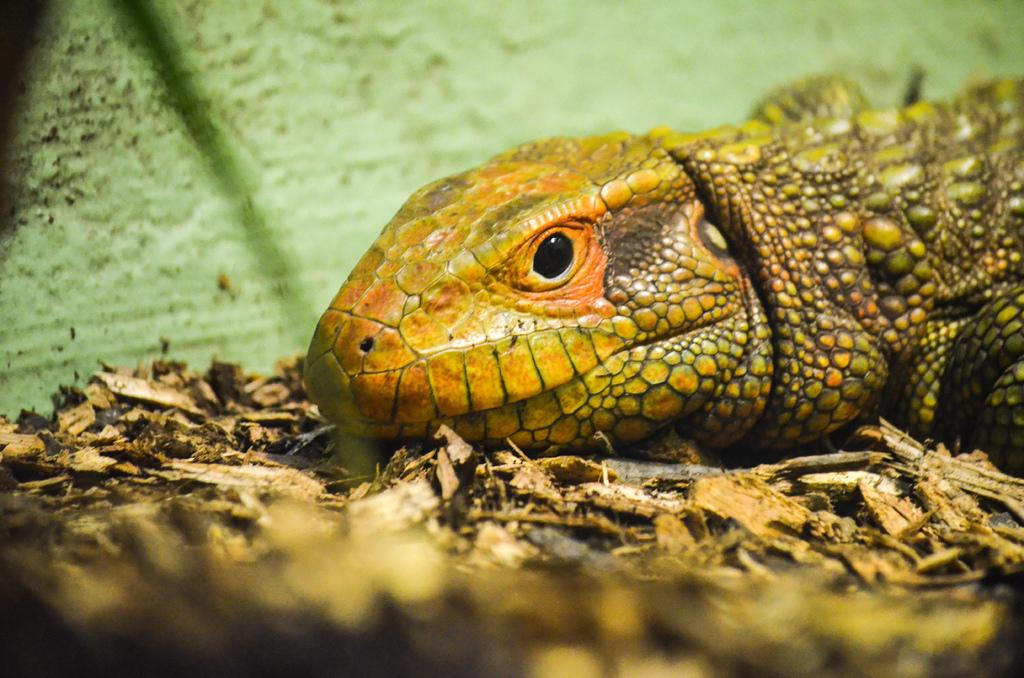What type of creature is present in the image? There is an animal in the image. What colors can be seen on the animal? The animal has brown, orange, and green colors. What is the color of the background in the image? The background of the image is green. What type of stove can be seen in the image? There is no stove present in the image; it features an animal with brown, orange, and green colors against a green background. How does the rake contribute to the image's composition? There is no rake present in the image; it only contains an animal and a green background. 